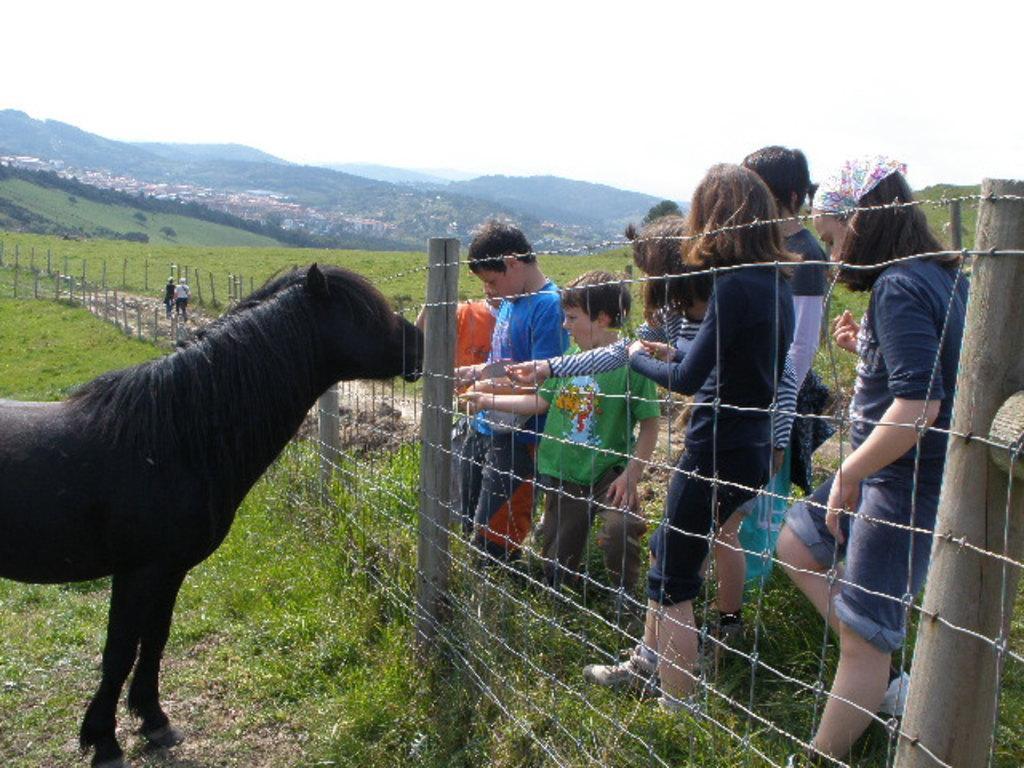In one or two sentences, can you explain what this image depicts? In this image there is a black horse on the left side. In front of it there is a fence through which there are people feeding the horse. In the background there are hills. On the ground there is grass. 